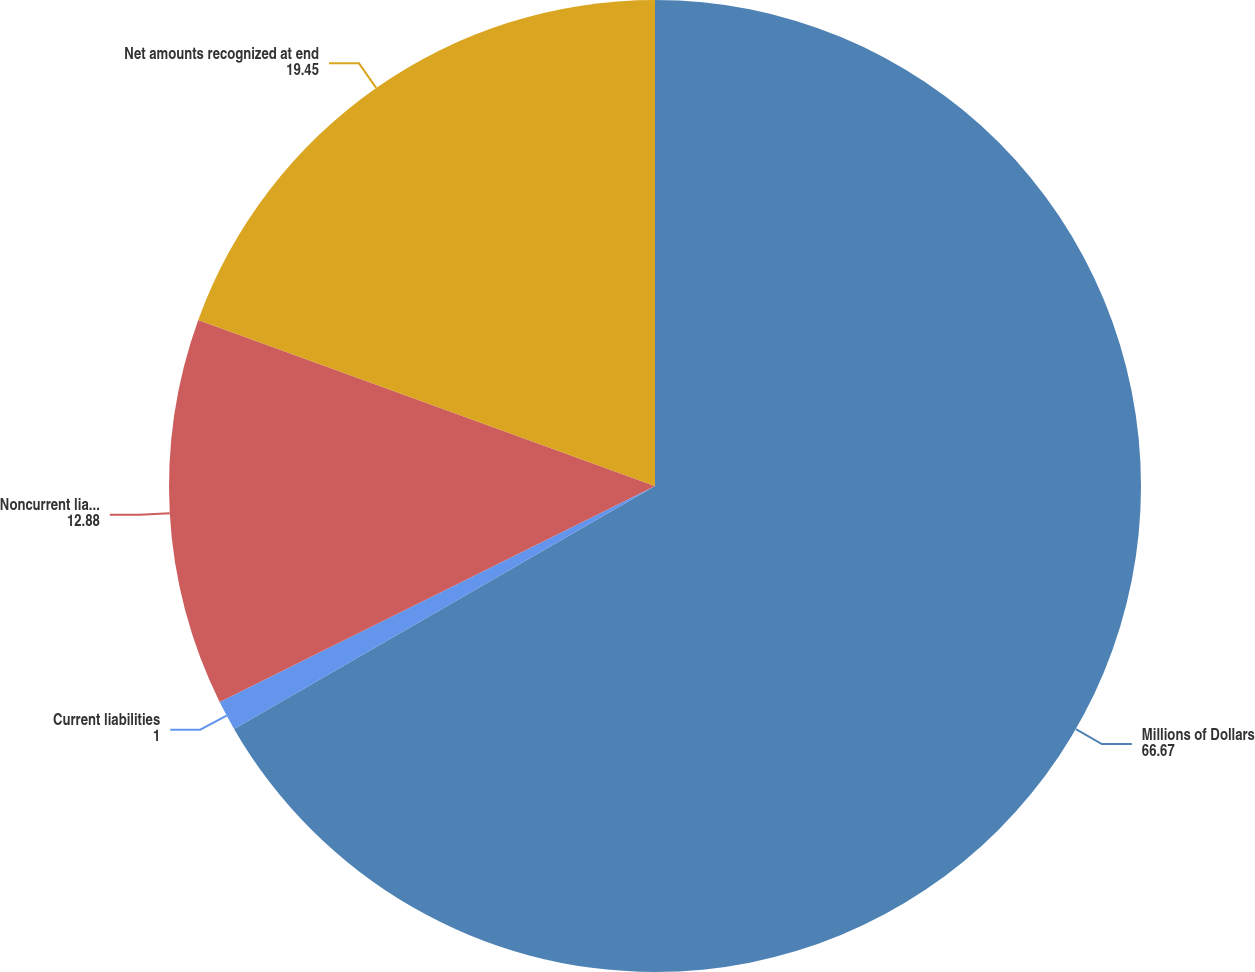<chart> <loc_0><loc_0><loc_500><loc_500><pie_chart><fcel>Millions of Dollars<fcel>Current liabilities<fcel>Noncurrent liabilities<fcel>Net amounts recognized at end<nl><fcel>66.67%<fcel>1.0%<fcel>12.88%<fcel>19.45%<nl></chart> 